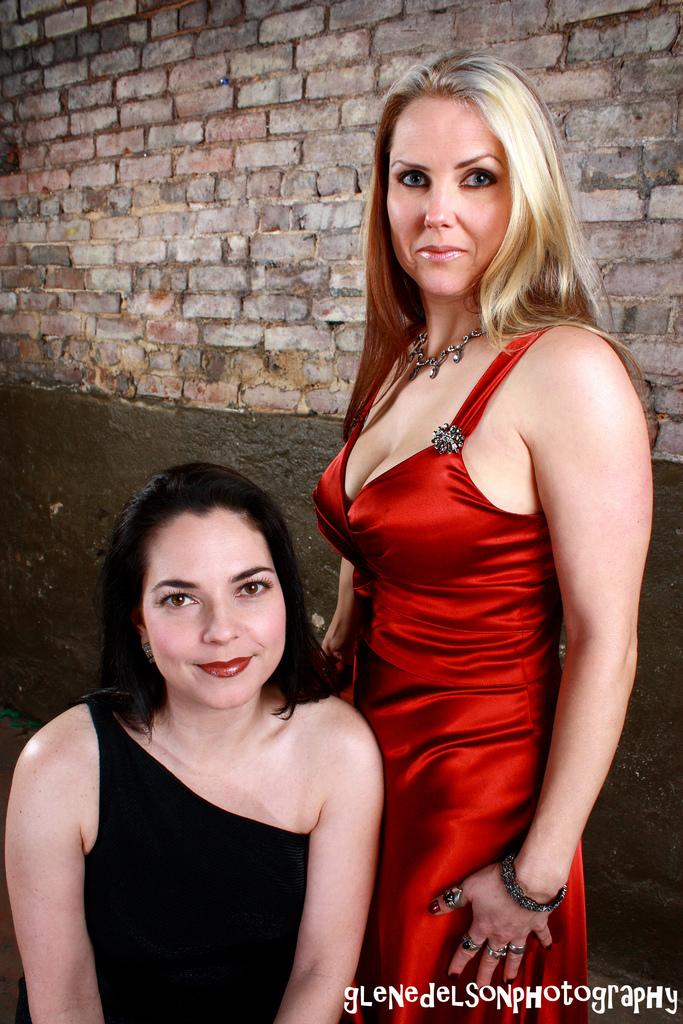How many people are in the image? There are two women in the image. What is behind the women in the image? There is a wall behind the women. Is there any text or marking in the image? Yes, there is a watermark in the bottom right corner of the image. Can you see a root growing out of the wall in the image? No, there is no root growing out of the wall in the image. Is there a dog visible in the image? No, there are no animals, including dogs, present in the image. 